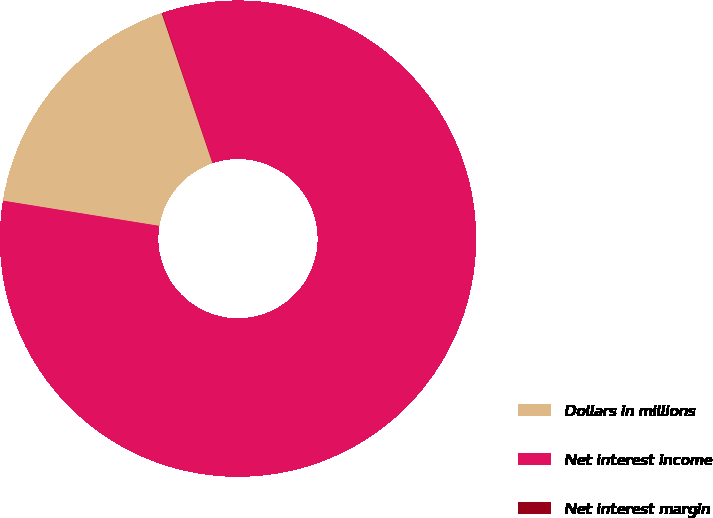Convert chart. <chart><loc_0><loc_0><loc_500><loc_500><pie_chart><fcel>Dollars in millions<fcel>Net interest income<fcel>Net interest margin<nl><fcel>17.26%<fcel>82.7%<fcel>0.03%<nl></chart> 